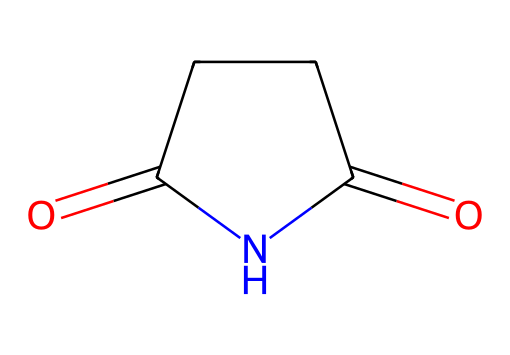What is the molecular formula of succinimide? To determine the molecular formula, count the number of carbon (C), hydrogen (H), nitrogen (N), and oxygen (O) atoms in the structure. There are four carbon atoms, five hydrogen atoms, one nitrogen atom, and two oxygen atoms. Therefore, the molecular formula is C4H5NO2.
Answer: C4H5NO2 How many rings are present in succinimide? By examining the structure, there is one cyclic component (the five-membered ring), which can be identified by the presence of both carbon and nitrogen atoms in a closed loop.
Answer: one What type of functional groups are present in succinimide? In the structure, you can identify a carbonyl group (C=O) and an imide group (R-CO-NH-CO-R) highlighting the essential imide characteristic, which consists of carbonyls adjacent to a nitrogen atom.
Answer: carbonyl and imide What is the total number of double bonds in the chemical structure of succinimide? From the structural representation, observe that there are two double bonds; one in the carbonyl functional groups and none in the ring, leading to a total count of two.
Answer: two Which atoms are involved in the ring structure of succinimide? The ring structure includes four carbon atoms and one nitrogen atom; you can clearly see that they form a closed loop in the molecular structure, which is essential for the imide classification.
Answer: four carbons and one nitrogen What is the significance of the nitrogen atom in succinimide? The nitrogen atom is key to characterizing succinimide as an imide, influencing both its chemical behavior and its role in pharmaceutical applications, particularly in anticonvulsant properties.
Answer: imide How many hydrogen atoms are directly attached to the nitrogen in succinimide? By analyzing the structure, you will find that there are no hydrogen atoms bonded directly to the nitrogen atom; instead, it is bonded to carbon within the ring, leading to a count of zero.
Answer: zero 